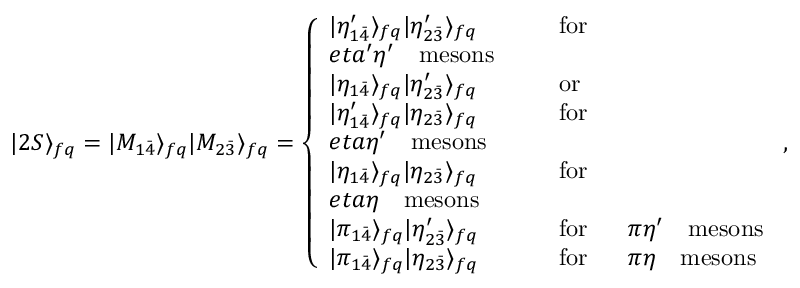Convert formula to latex. <formula><loc_0><loc_0><loc_500><loc_500>| 2 S \rangle _ { f q } = | M _ { 1 \bar { 4 } } \rangle _ { f q } | M _ { 2 \bar { 3 } } \rangle _ { f q } = \left \{ \begin{array} { l l } { { | \eta _ { 1 \bar { 4 } } ^ { \prime } \rangle _ { f q } | \eta _ { 2 \bar { 3 } } ^ { \prime } \rangle _ { f q } } } & { \quad \ f o r \quad } \\ { { e t a ^ { \prime } \eta ^ { \prime } \quad m e s o n s } } \\ { { | \eta _ { 1 \bar { 4 } } \rangle _ { f q } | \eta _ { 2 \bar { 3 } } ^ { \prime } \rangle _ { f q } } } & { \quad \ o r } \\ { { | \eta _ { 1 \bar { 4 } } ^ { \prime } \rangle _ { f q } | \eta _ { 2 \bar { 3 } } \rangle _ { f q } } } & { \quad \ f o r \quad } \\ { { e t a \eta ^ { \prime } \quad m e s o n s } } \\ { { | \eta _ { 1 \bar { 4 } } \rangle _ { f q } | \eta _ { 2 \bar { 3 } } \rangle _ { f q } } } & { \quad \ f o r \quad } \\ { e t a \eta \quad m e s o n s } \\ { { | \pi _ { 1 \bar { 4 } } \rangle _ { f q } | \eta _ { 2 \bar { 3 } } ^ { \prime } \rangle _ { f q } } } & { { \quad \ f o r \quad \ \pi \eta ^ { \prime } \quad m e s o n s } } \\ { { | \pi _ { 1 \bar { 4 } } \rangle _ { f q } | \eta _ { 2 \bar { 3 } } \rangle _ { f q } } } & { \quad \ f o r \quad \ \pi \eta \quad m e s o n s } \end{array} ,</formula> 